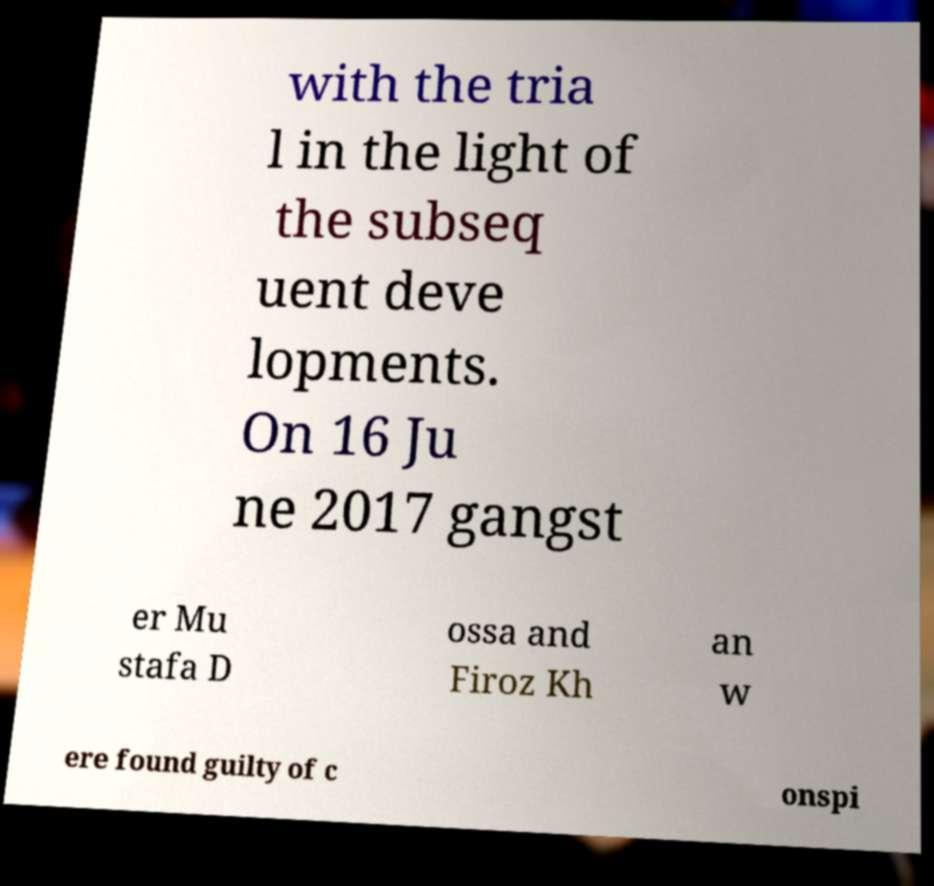Could you extract and type out the text from this image? with the tria l in the light of the subseq uent deve lopments. On 16 Ju ne 2017 gangst er Mu stafa D ossa and Firoz Kh an w ere found guilty of c onspi 